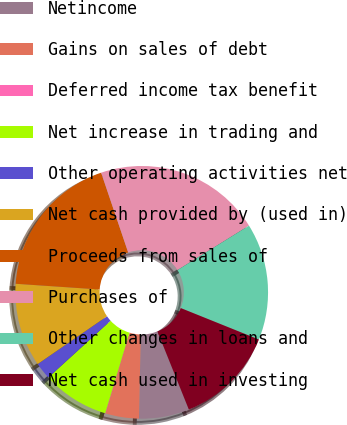Convert chart to OTSL. <chart><loc_0><loc_0><loc_500><loc_500><pie_chart><fcel>Netincome<fcel>Gains on sales of debt<fcel>Deferred income tax benefit<fcel>Net increase in trading and<fcel>Other operating activities net<fcel>Net cash provided by (used in)<fcel>Proceeds from sales of<fcel>Purchases of<fcel>Other changes in loans and<fcel>Net cash used in investing<nl><fcel>6.43%<fcel>4.3%<fcel>0.03%<fcel>8.56%<fcel>2.16%<fcel>10.69%<fcel>18.72%<fcel>21.35%<fcel>14.95%<fcel>12.82%<nl></chart> 